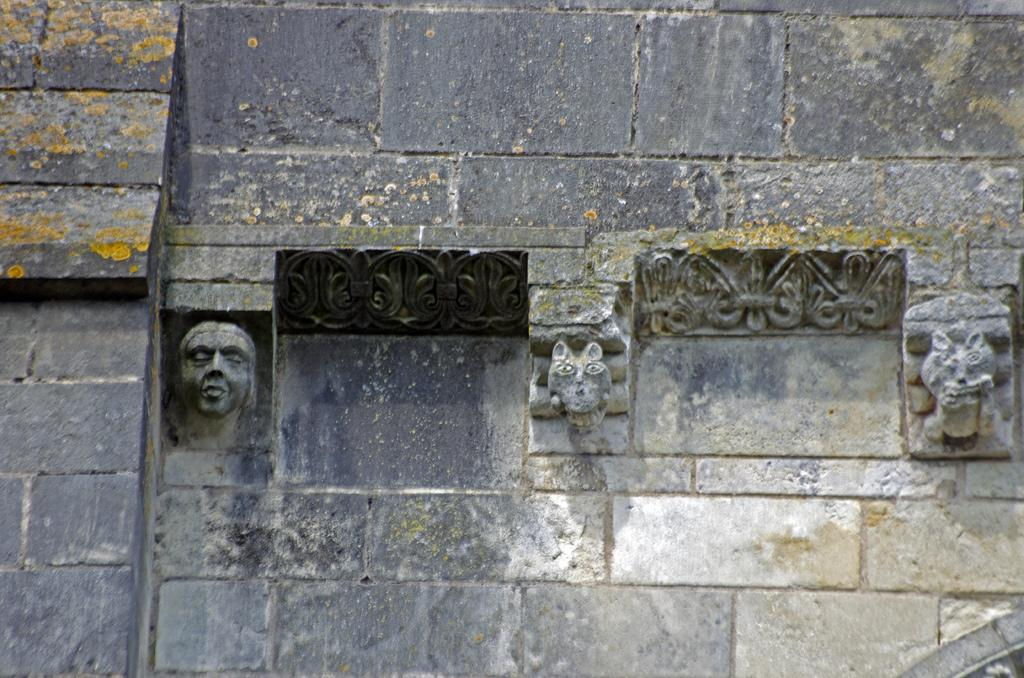What is the main feature of the image? The main feature of the image is a wall. What can be seen on the wall? The wall has structures of human faces and animals. How many pockets are visible on the wall in the image? There are no pockets visible on the wall in the image. 